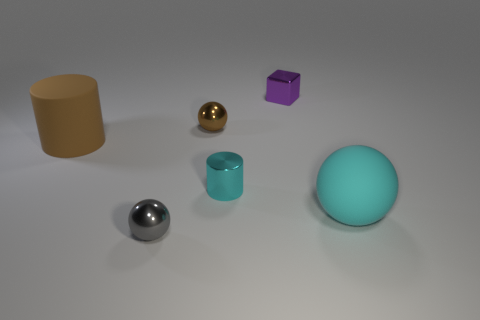Are there any other things that are the same shape as the small purple thing?
Your response must be concise. No. Do the tiny gray object and the big thing that is left of the metallic cube have the same material?
Give a very brief answer. No. There is a small metallic ball behind the big rubber sphere; is its color the same as the big matte cylinder?
Offer a very short reply. Yes. What is the ball that is on the right side of the tiny gray object and to the left of the large matte ball made of?
Provide a succinct answer. Metal. How big is the shiny block?
Give a very brief answer. Small. Do the matte cylinder and the small shiny ball that is behind the large brown rubber object have the same color?
Make the answer very short. Yes. How many other objects are the same color as the matte ball?
Keep it short and to the point. 1. Do the ball behind the small cylinder and the rubber thing in front of the brown rubber thing have the same size?
Offer a very short reply. No. There is a metallic thing that is on the left side of the brown metal thing; what is its color?
Your answer should be compact. Gray. Is the number of brown things that are to the right of the tiny metallic cylinder less than the number of tiny brown balls?
Offer a very short reply. Yes. 